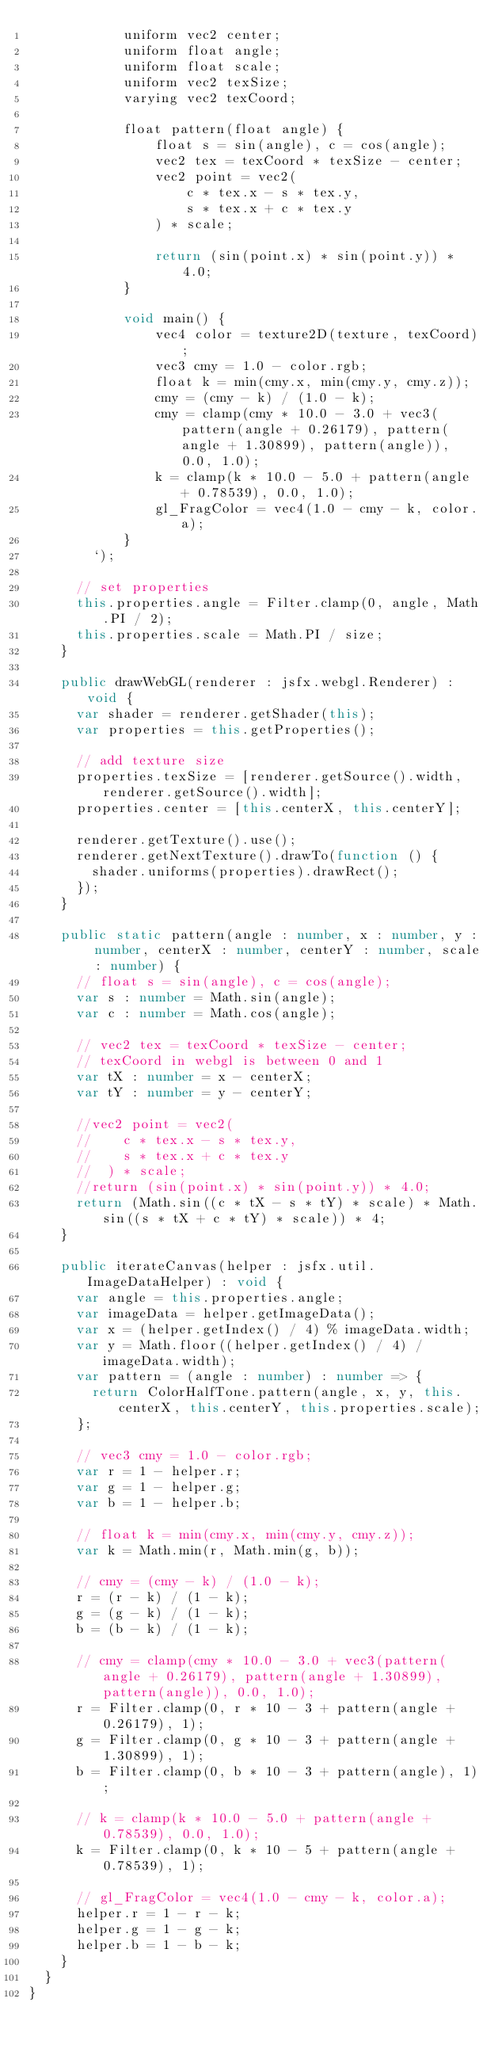Convert code to text. <code><loc_0><loc_0><loc_500><loc_500><_TypeScript_>            uniform vec2 center;
            uniform float angle;
            uniform float scale;
            uniform vec2 texSize;
            varying vec2 texCoord;

            float pattern(float angle) {
                float s = sin(angle), c = cos(angle);
                vec2 tex = texCoord * texSize - center;
                vec2 point = vec2(
                    c * tex.x - s * tex.y,
                    s * tex.x + c * tex.y
                ) * scale;

                return (sin(point.x) * sin(point.y)) * 4.0;
            }

            void main() {
                vec4 color = texture2D(texture, texCoord);
                vec3 cmy = 1.0 - color.rgb;
                float k = min(cmy.x, min(cmy.y, cmy.z));
                cmy = (cmy - k) / (1.0 - k);
                cmy = clamp(cmy * 10.0 - 3.0 + vec3(pattern(angle + 0.26179), pattern(angle + 1.30899), pattern(angle)), 0.0, 1.0);
                k = clamp(k * 10.0 - 5.0 + pattern(angle + 0.78539), 0.0, 1.0);
                gl_FragColor = vec4(1.0 - cmy - k, color.a);
            }
        `);

      // set properties
      this.properties.angle = Filter.clamp(0, angle, Math.PI / 2);
      this.properties.scale = Math.PI / size;
    }

    public drawWebGL(renderer : jsfx.webgl.Renderer) : void {
      var shader = renderer.getShader(this);
      var properties = this.getProperties();

      // add texture size
      properties.texSize = [renderer.getSource().width, renderer.getSource().width];
      properties.center = [this.centerX, this.centerY];

      renderer.getTexture().use();
      renderer.getNextTexture().drawTo(function () {
        shader.uniforms(properties).drawRect();
      });
    }

    public static pattern(angle : number, x : number, y : number, centerX : number, centerY : number, scale : number) {
      // float s = sin(angle), c = cos(angle);
      var s : number = Math.sin(angle);
      var c : number = Math.cos(angle);

      // vec2 tex = texCoord * texSize - center;
      // texCoord in webgl is between 0 and 1
      var tX : number = x - centerX;
      var tY : number = y - centerY;

      //vec2 point = vec2(
      //    c * tex.x - s * tex.y,
      //    s * tex.x + c * tex.y
      //  ) * scale;
      //return (sin(point.x) * sin(point.y)) * 4.0;
      return (Math.sin((c * tX - s * tY) * scale) * Math.sin((s * tX + c * tY) * scale)) * 4;
    }

    public iterateCanvas(helper : jsfx.util.ImageDataHelper) : void {
      var angle = this.properties.angle;
      var imageData = helper.getImageData();
      var x = (helper.getIndex() / 4) % imageData.width;
      var y = Math.floor((helper.getIndex() / 4) / imageData.width);
      var pattern = (angle : number) : number => {
        return ColorHalfTone.pattern(angle, x, y, this.centerX, this.centerY, this.properties.scale);
      };

      // vec3 cmy = 1.0 - color.rgb;
      var r = 1 - helper.r;
      var g = 1 - helper.g;
      var b = 1 - helper.b;

      // float k = min(cmy.x, min(cmy.y, cmy.z));
      var k = Math.min(r, Math.min(g, b));

      // cmy = (cmy - k) / (1.0 - k);
      r = (r - k) / (1 - k);
      g = (g - k) / (1 - k);
      b = (b - k) / (1 - k);

      // cmy = clamp(cmy * 10.0 - 3.0 + vec3(pattern(angle + 0.26179), pattern(angle + 1.30899), pattern(angle)), 0.0, 1.0);
      r = Filter.clamp(0, r * 10 - 3 + pattern(angle + 0.26179), 1);
      g = Filter.clamp(0, g * 10 - 3 + pattern(angle + 1.30899), 1);
      b = Filter.clamp(0, b * 10 - 3 + pattern(angle), 1);

      // k = clamp(k * 10.0 - 5.0 + pattern(angle + 0.78539), 0.0, 1.0);
      k = Filter.clamp(0, k * 10 - 5 + pattern(angle + 0.78539), 1);

      // gl_FragColor = vec4(1.0 - cmy - k, color.a);
      helper.r = 1 - r - k;
      helper.g = 1 - g - k;
      helper.b = 1 - b - k;
    }
  }
}
</code> 